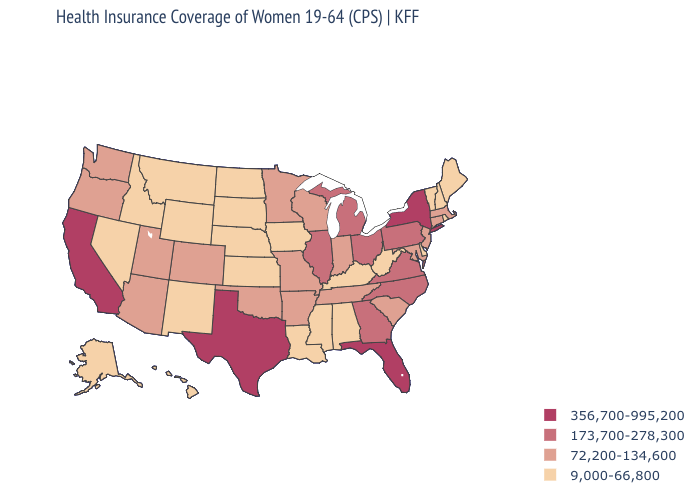How many symbols are there in the legend?
Write a very short answer. 4. Which states hav the highest value in the South?
Be succinct. Florida, Texas. Among the states that border Arkansas , which have the highest value?
Be succinct. Texas. Name the states that have a value in the range 9,000-66,800?
Short answer required. Alabama, Alaska, Delaware, Hawaii, Idaho, Iowa, Kansas, Kentucky, Louisiana, Maine, Mississippi, Montana, Nebraska, Nevada, New Hampshire, New Mexico, North Dakota, Rhode Island, South Dakota, Vermont, West Virginia, Wyoming. How many symbols are there in the legend?
Write a very short answer. 4. Name the states that have a value in the range 173,700-278,300?
Give a very brief answer. Georgia, Illinois, Michigan, North Carolina, Ohio, Pennsylvania, Virginia. What is the value of Maryland?
Be succinct. 72,200-134,600. Which states have the lowest value in the West?
Give a very brief answer. Alaska, Hawaii, Idaho, Montana, Nevada, New Mexico, Wyoming. Does Indiana have the highest value in the MidWest?
Short answer required. No. Which states have the lowest value in the Northeast?
Be succinct. Maine, New Hampshire, Rhode Island, Vermont. Name the states that have a value in the range 9,000-66,800?
Give a very brief answer. Alabama, Alaska, Delaware, Hawaii, Idaho, Iowa, Kansas, Kentucky, Louisiana, Maine, Mississippi, Montana, Nebraska, Nevada, New Hampshire, New Mexico, North Dakota, Rhode Island, South Dakota, Vermont, West Virginia, Wyoming. Does California have the highest value in the USA?
Concise answer only. Yes. What is the value of Arkansas?
Keep it brief. 72,200-134,600. Which states have the highest value in the USA?
Short answer required. California, Florida, New York, Texas. What is the value of Connecticut?
Concise answer only. 72,200-134,600. 